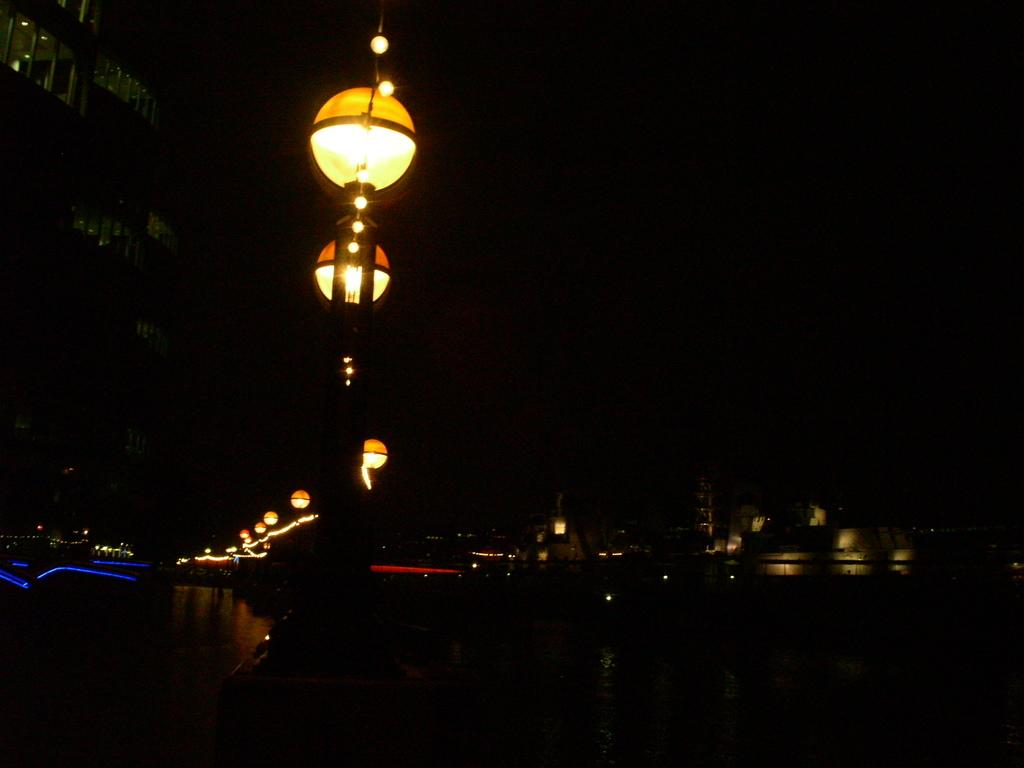What type of structures can be seen in the image? There are street light poles and buildings in the image. What can be observed in the sky in the image? The sky appears dark in the image. How would you describe the overall appearance of the image? The image has a slightly dark appearance. What type of hat is the street light pole wearing in the image? There are no hats present in the image, as street light poles do not wear hats. What is the zinc content of the buildings in the image? There is no information about the zinc content of the buildings in the image, as it does not provide any details about the materials used in their construction. 